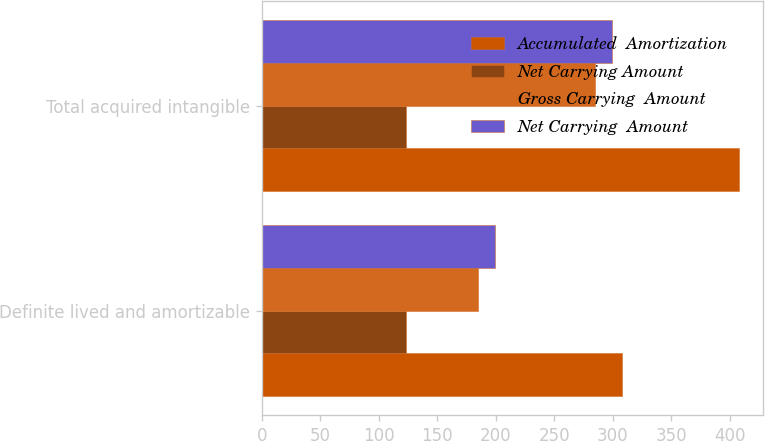Convert chart. <chart><loc_0><loc_0><loc_500><loc_500><stacked_bar_chart><ecel><fcel>Definite lived and amortizable<fcel>Total acquired intangible<nl><fcel>Accumulated  Amortization<fcel>308<fcel>408<nl><fcel>Net Carrying Amount<fcel>123<fcel>123<nl><fcel>Gross Carrying  Amount<fcel>185<fcel>285<nl><fcel>Net Carrying  Amount<fcel>199<fcel>299<nl></chart> 